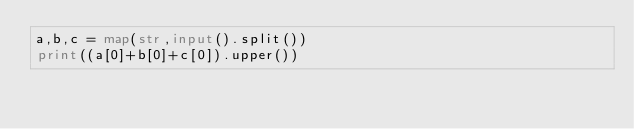<code> <loc_0><loc_0><loc_500><loc_500><_Python_>a,b,c = map(str,input().split())
print((a[0]+b[0]+c[0]).upper())</code> 